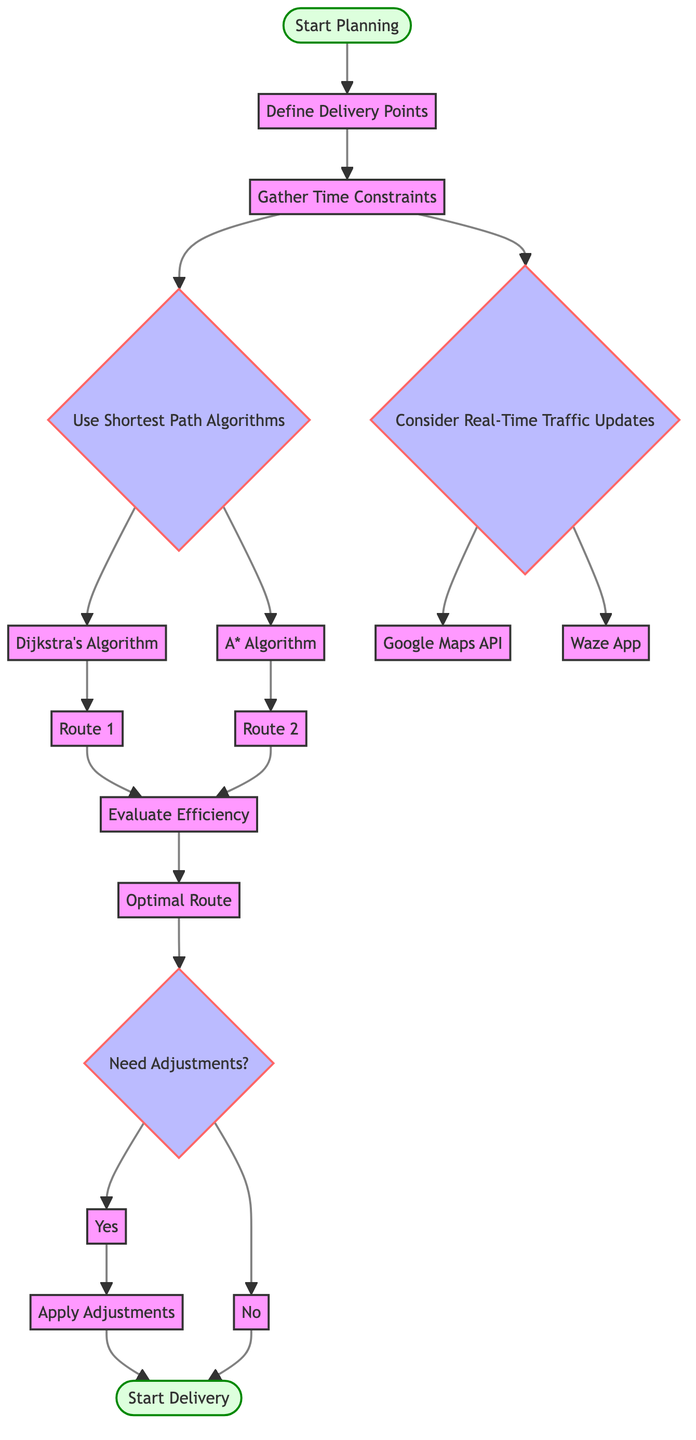What's the starting node in the diagram? The starting node is labeled "Start Planning," which is the initial step of the flowchart leading to further actions.
Answer: Start Planning How many algorithms are mentioned in the diagram for planning delivery routes? There are three algorithms mentioned in the diagram: Dijkstra's Algorithm, A* Algorithm, and the Google Maps API, as well as the Waze App. Counting them gives a total of four.
Answer: 4 What is the outcome of evaluating the efficiency of the candidate routes? After evaluating efficiency, the outcome is determining the "Optimal Route," which is a direct path after the evaluation step in the diagram.
Answer: Optimal Route Which node leads to the decision about adjustments? The node that leads to adjustments is "Evaluate Efficiency," where the evaluation results in the need for potential adjustments or moving directly to start delivery.
Answer: Evaluate Efficiency What happens if adjustments are needed after evaluating efficiency? If adjustments are needed, the next step is labeled "Apply Adjustments," indicating that modifications to the route planning will be made before proceeding to delivery.
Answer: Apply Adjustments Which node corresponds to the use of real-time traffic updates? The node that corresponds to real-time traffic updates is labeled "Consider Real-Time Traffic Updates," which is a decision point parallel to using shortest path algorithms.
Answer: Consider Real-Time Traffic Updates What is the final node in the flowchart? The final node in the flowchart is labeled "Start Delivery," which indicates the completion of the planning process and the initiation of the delivery phase.
Answer: Start Delivery Which algorithm is associated with the node labeled Route 1? The algorithm associated with "Route 1" is Dijkstra's Algorithm, which is one of the paths stemming from the shortest path algorithms decision.
Answer: Dijkstra's Algorithm What is the purpose of the node labeled "Need Adjustments?" The purpose of the "Need Adjustments?" node is to evaluate whether changes to the planned route are necessary based on the efficiency results obtained in the previous step.
Answer: Need Adjustments? 